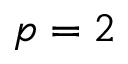<formula> <loc_0><loc_0><loc_500><loc_500>p = 2</formula> 